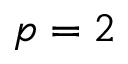<formula> <loc_0><loc_0><loc_500><loc_500>p = 2</formula> 